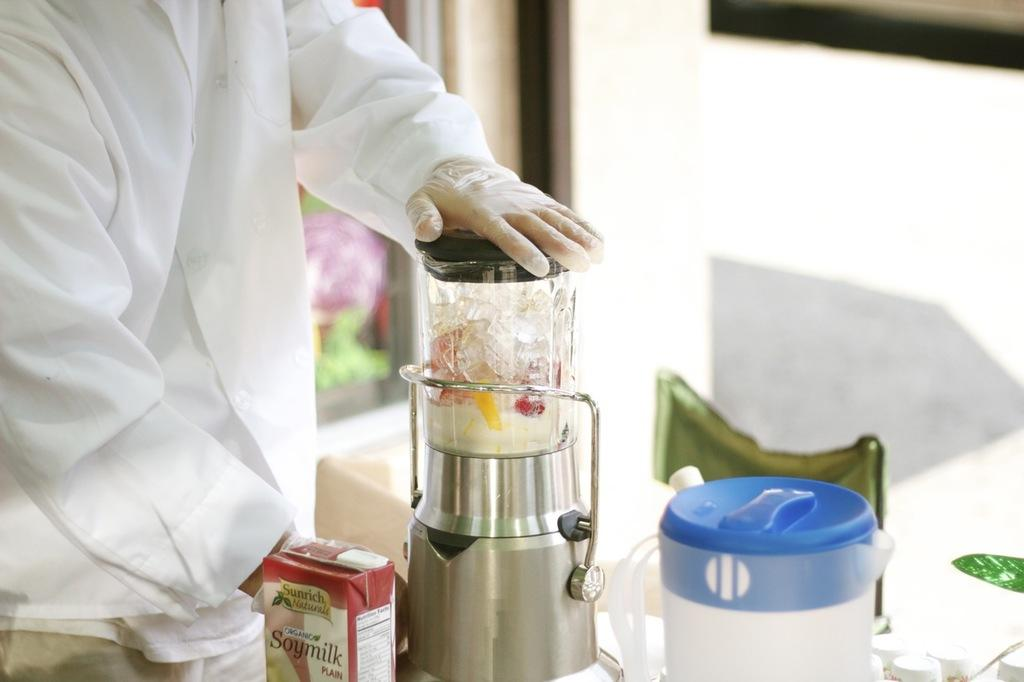Provide a one-sentence caption for the provided image. The blender is mixing a bunch of things including soy milk. 